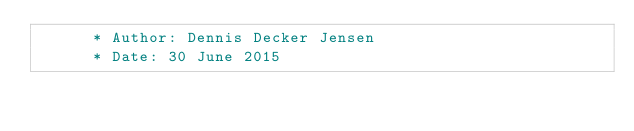<code> <loc_0><loc_0><loc_500><loc_500><_COBOL_>      * Author: Dennis Decker Jensen
      * Date: 30 June 2015</code> 